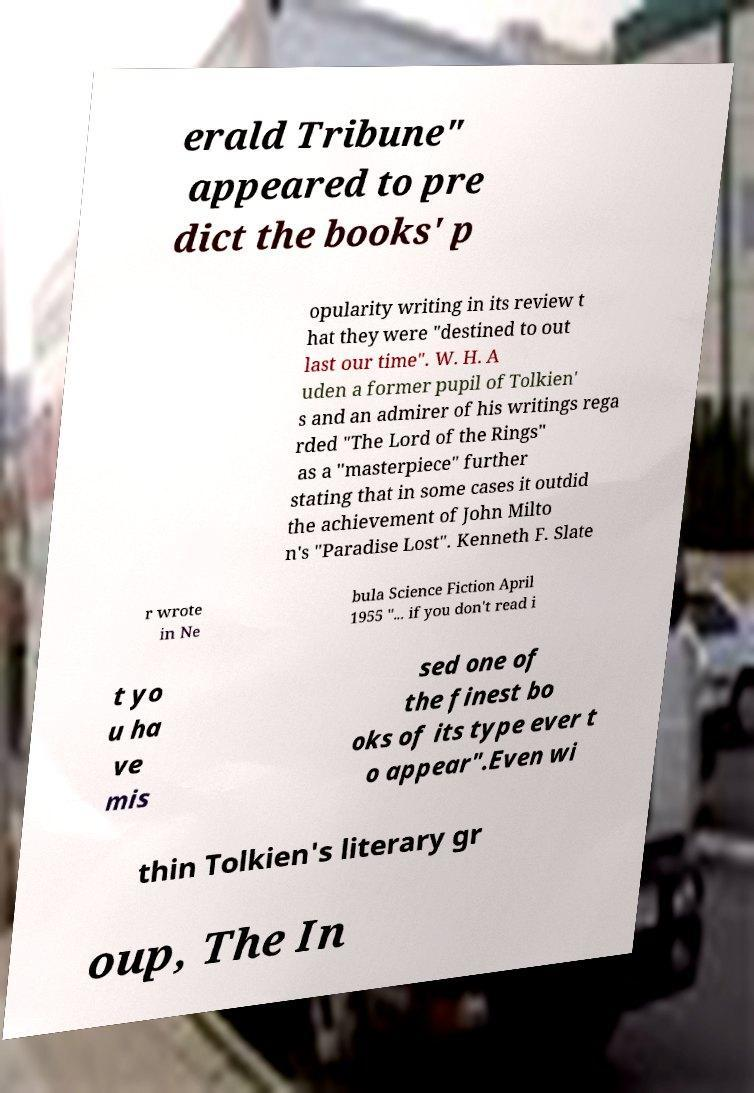Could you extract and type out the text from this image? erald Tribune" appeared to pre dict the books' p opularity writing in its review t hat they were "destined to out last our time". W. H. A uden a former pupil of Tolkien' s and an admirer of his writings rega rded "The Lord of the Rings" as a "masterpiece" further stating that in some cases it outdid the achievement of John Milto n's "Paradise Lost". Kenneth F. Slate r wrote in Ne bula Science Fiction April 1955 "... if you don't read i t yo u ha ve mis sed one of the finest bo oks of its type ever t o appear".Even wi thin Tolkien's literary gr oup, The In 